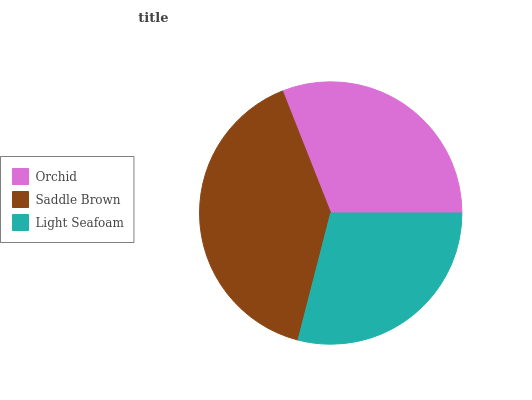Is Light Seafoam the minimum?
Answer yes or no. Yes. Is Saddle Brown the maximum?
Answer yes or no. Yes. Is Saddle Brown the minimum?
Answer yes or no. No. Is Light Seafoam the maximum?
Answer yes or no. No. Is Saddle Brown greater than Light Seafoam?
Answer yes or no. Yes. Is Light Seafoam less than Saddle Brown?
Answer yes or no. Yes. Is Light Seafoam greater than Saddle Brown?
Answer yes or no. No. Is Saddle Brown less than Light Seafoam?
Answer yes or no. No. Is Orchid the high median?
Answer yes or no. Yes. Is Orchid the low median?
Answer yes or no. Yes. Is Light Seafoam the high median?
Answer yes or no. No. Is Light Seafoam the low median?
Answer yes or no. No. 